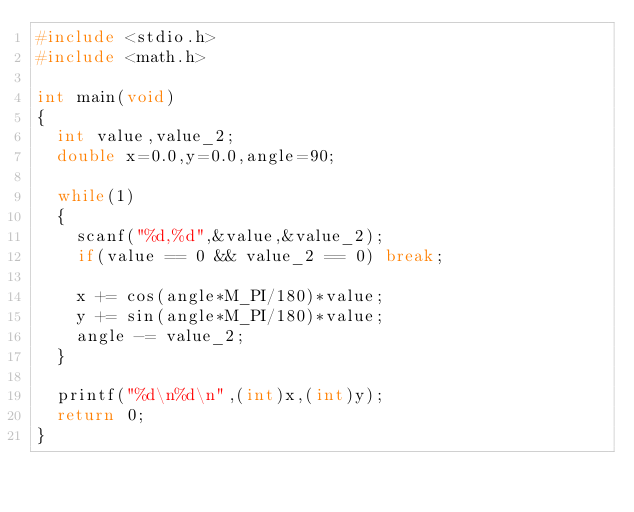<code> <loc_0><loc_0><loc_500><loc_500><_C_>#include <stdio.h>
#include <math.h>

int main(void)
{
	int value,value_2;
	double x=0.0,y=0.0,angle=90;

	while(1)
	{
		scanf("%d,%d",&value,&value_2);
		if(value == 0 && value_2 == 0) break;

		x += cos(angle*M_PI/180)*value;
		y += sin(angle*M_PI/180)*value;
		angle -= value_2;
	}

	printf("%d\n%d\n",(int)x,(int)y);
	return 0;
}</code> 